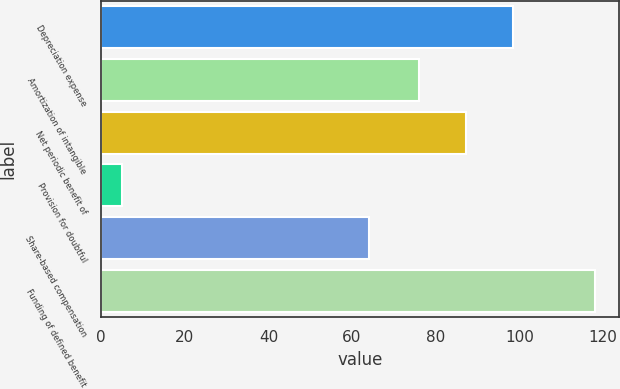Convert chart. <chart><loc_0><loc_0><loc_500><loc_500><bar_chart><fcel>Depreciation expense<fcel>Amortization of intangible<fcel>Net periodic benefit of<fcel>Provision for doubtful<fcel>Share-based compensation<fcel>Funding of defined benefit<nl><fcel>98.6<fcel>76<fcel>87.3<fcel>5<fcel>64<fcel>118<nl></chart> 